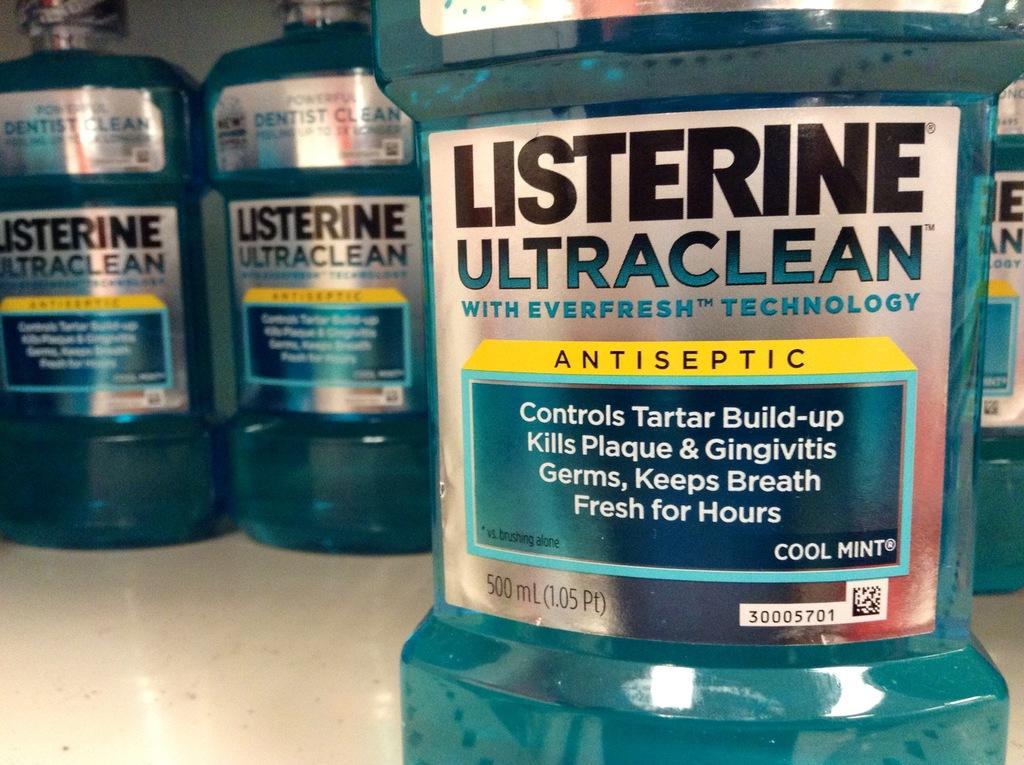What kind of technology does listerine have?
Your response must be concise. Everfresh. What is the brand of moutwash?
Offer a terse response. Listerine. 